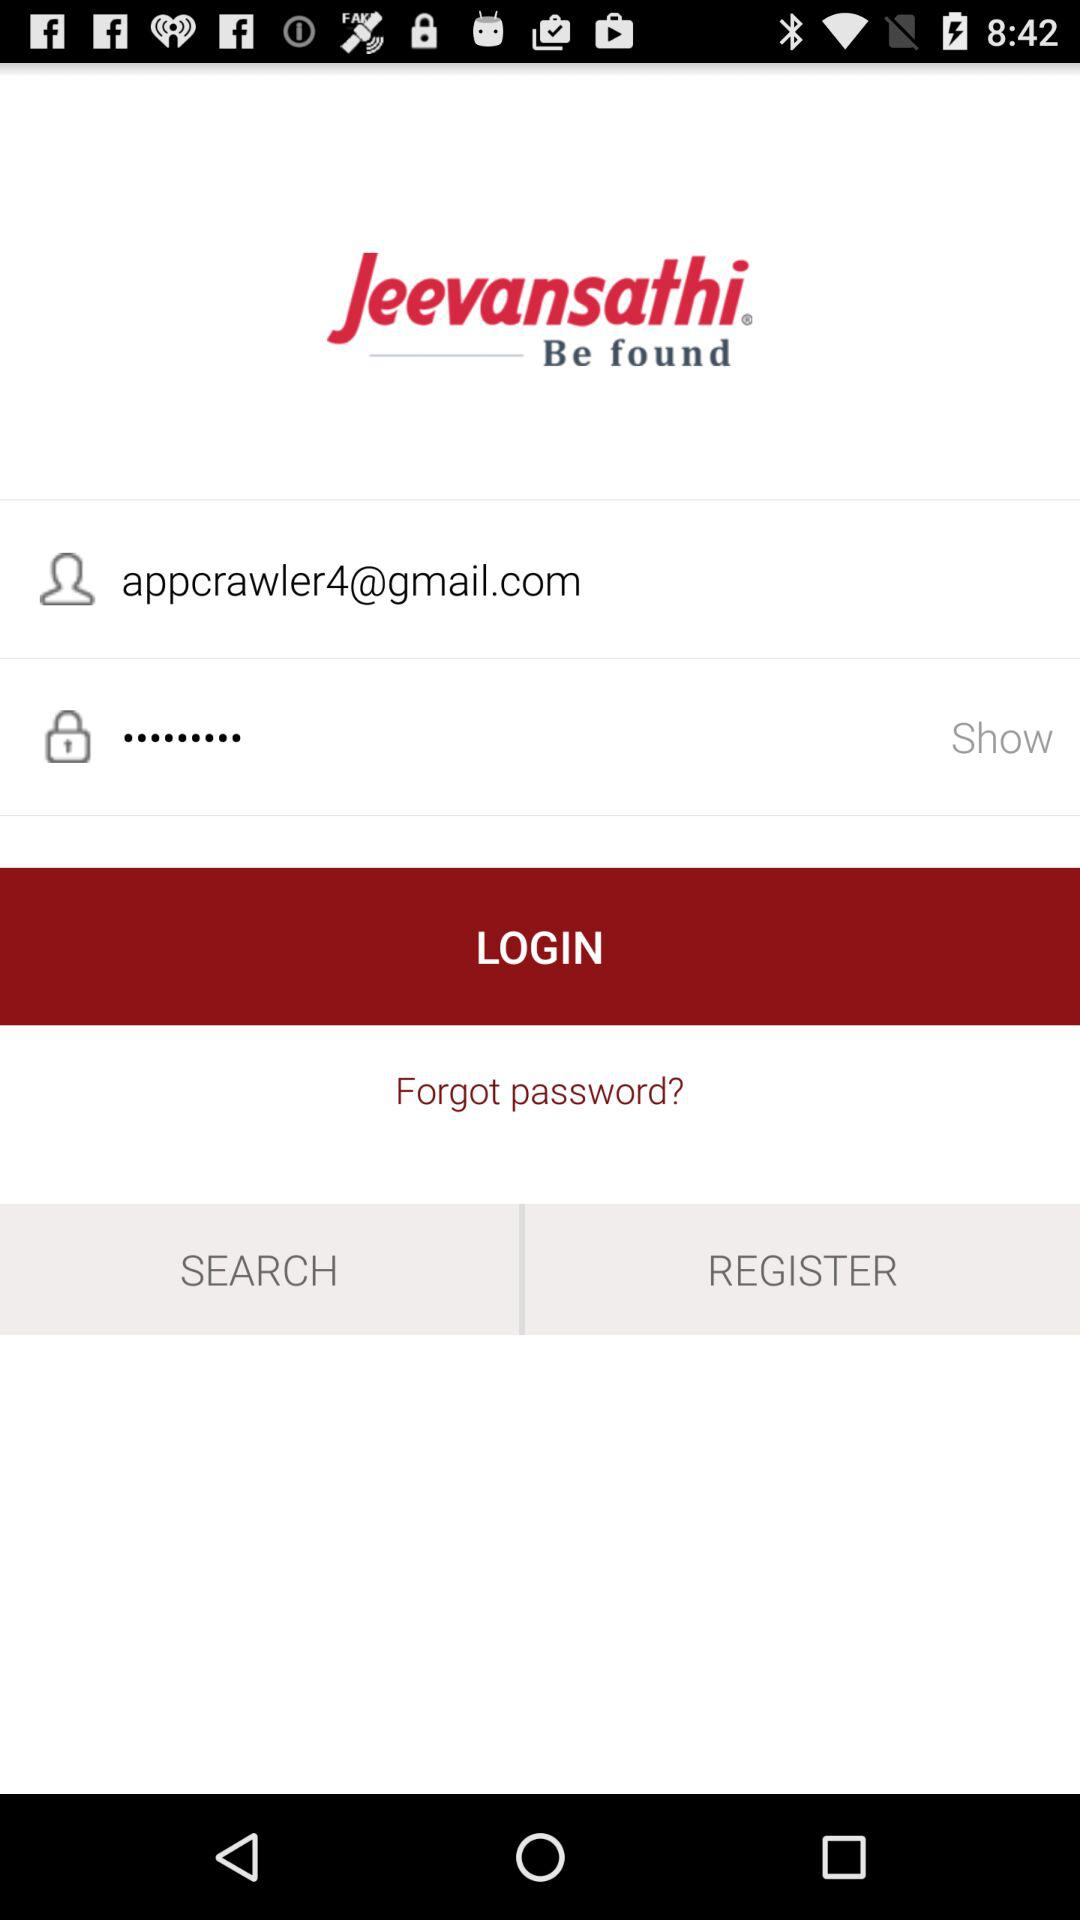How many text inputs are in the login form?
Answer the question using a single word or phrase. 2 